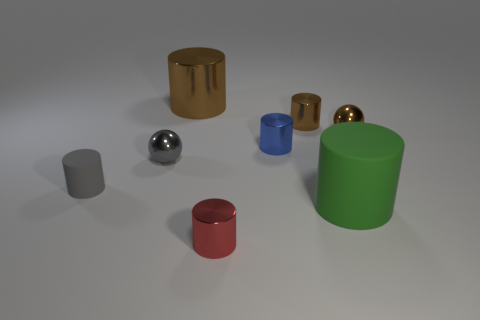What is the material of the object that is in front of the gray matte thing and behind the red thing?
Your answer should be very brief. Rubber. There is a shiny thing that is in front of the gray rubber cylinder behind the large object on the right side of the tiny brown shiny cylinder; what size is it?
Offer a very short reply. Small. Is the number of green rubber cylinders greater than the number of large red metallic cylinders?
Ensure brevity in your answer.  Yes. Is the brown object to the right of the large green matte cylinder made of the same material as the blue cylinder?
Your response must be concise. Yes. Are there fewer tiny gray matte objects than brown metallic objects?
Give a very brief answer. Yes. There is a gray thing that is to the left of the gray sphere that is left of the big metallic object; are there any gray cylinders behind it?
Your answer should be compact. No. There is a rubber object that is to the left of the blue object; is its shape the same as the big metal thing?
Your answer should be very brief. Yes. Is the number of green things that are left of the tiny gray cylinder greater than the number of large shiny things?
Provide a short and direct response. No. Do the large cylinder that is to the left of the big green thing and the large rubber cylinder have the same color?
Your answer should be compact. No. Are there any other things that are the same color as the small rubber cylinder?
Your answer should be compact. Yes. 